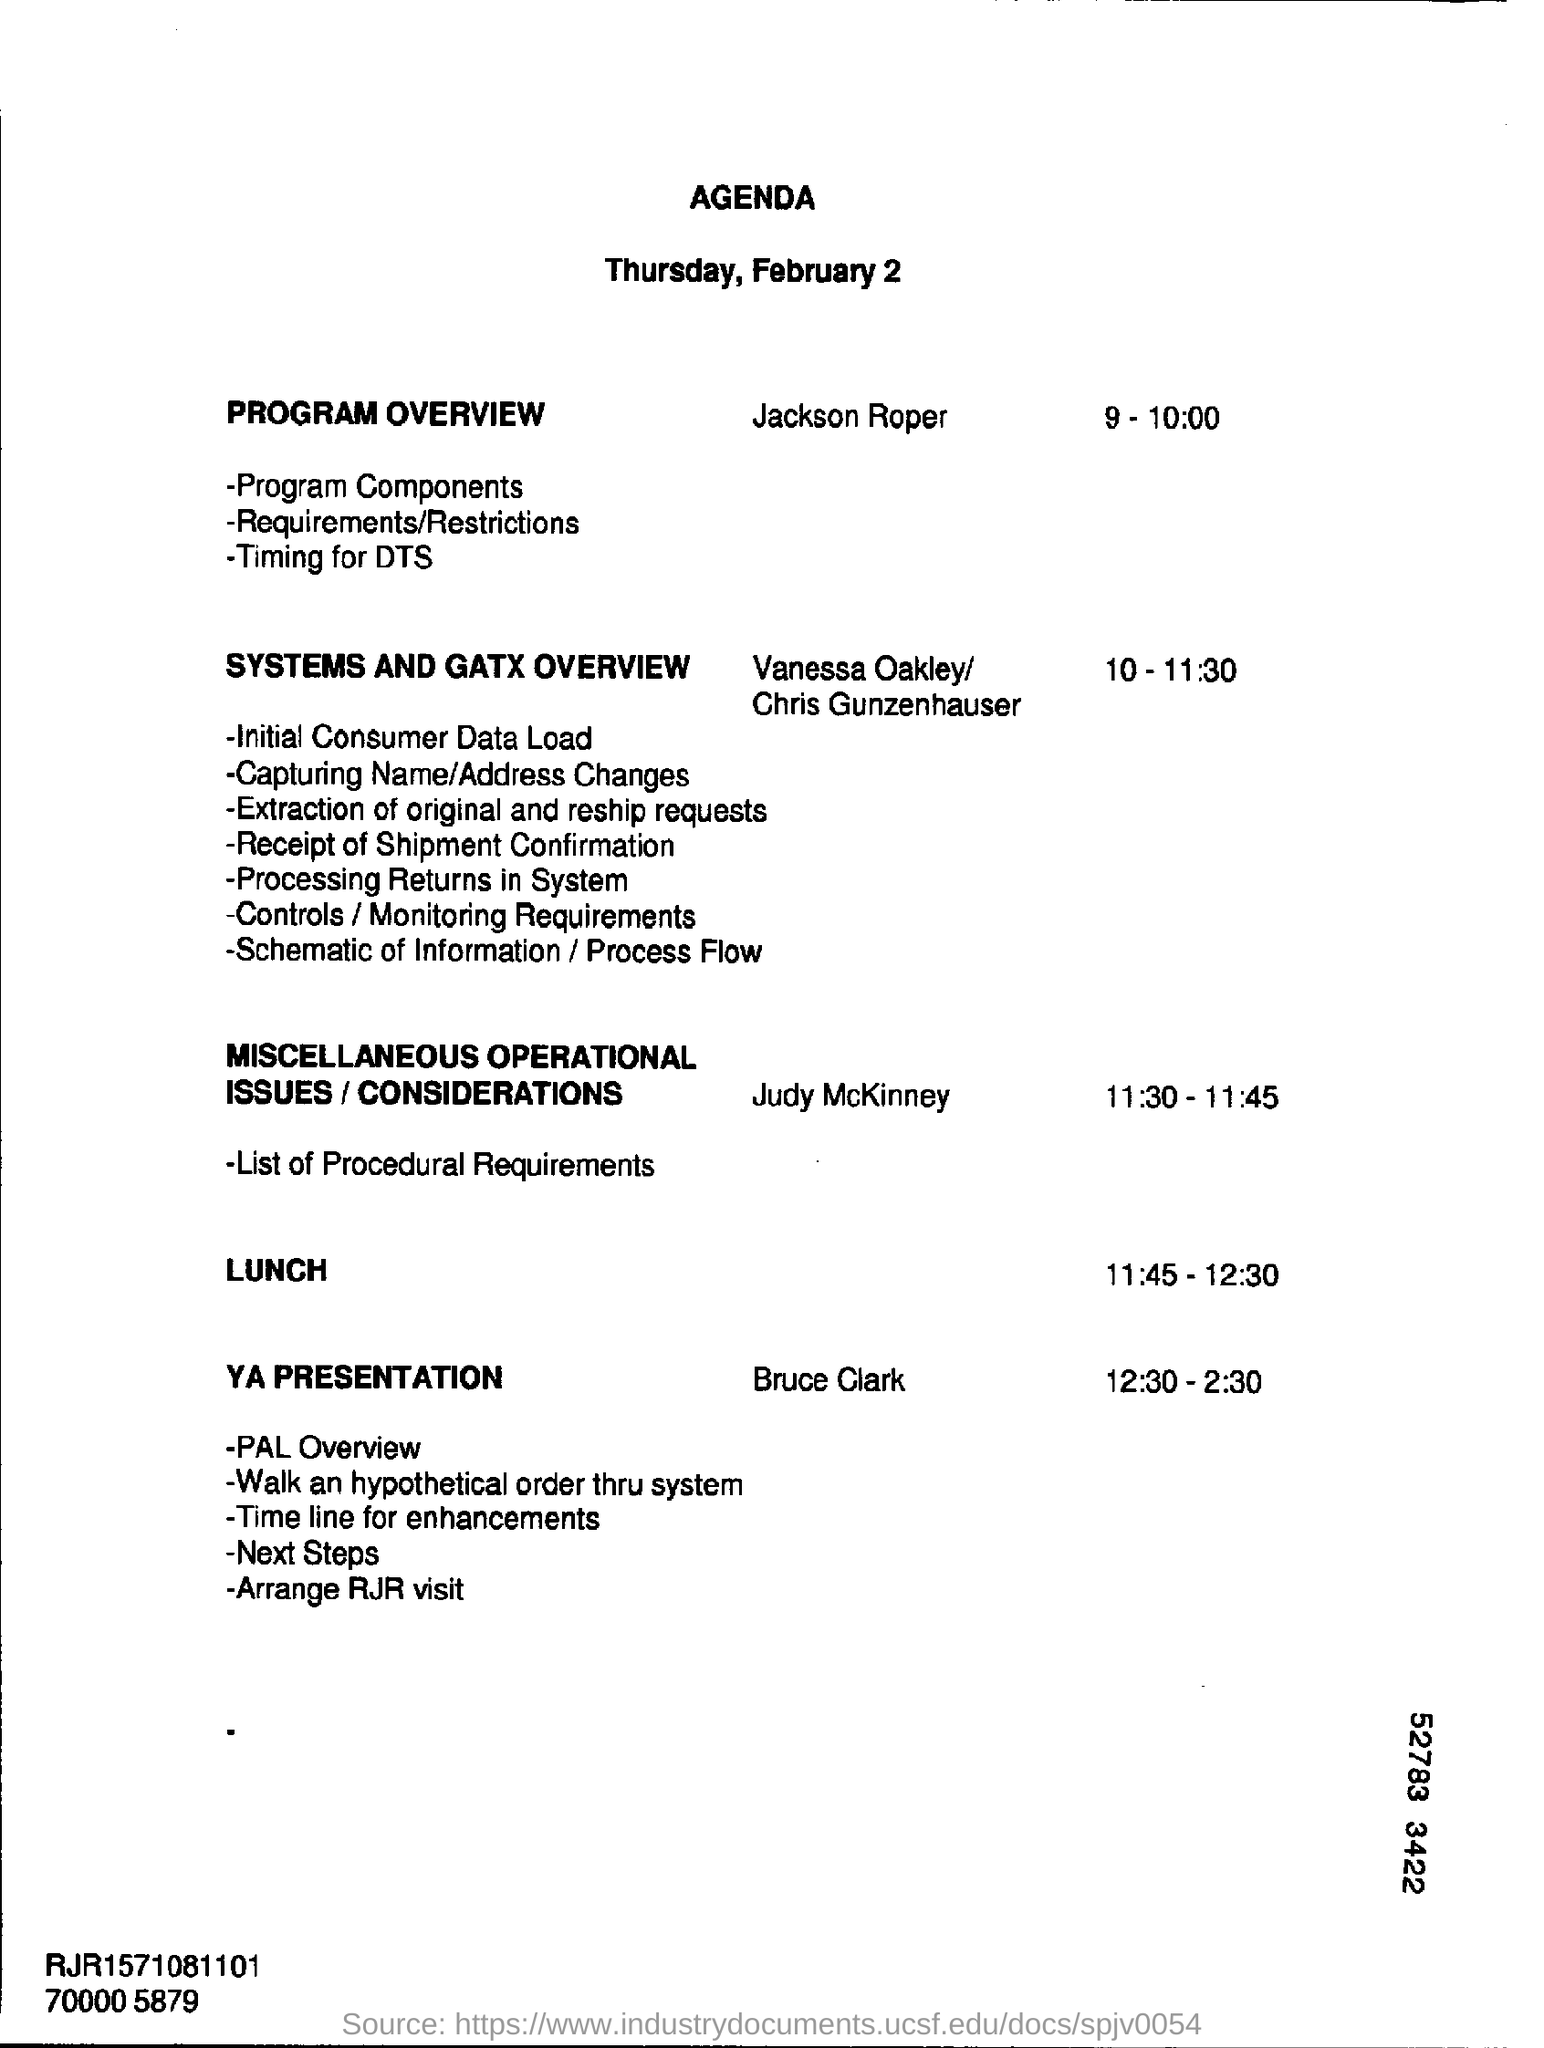What is time mentioned for "Time for miscellaneous operational issues?
Make the answer very short. 11.30-11.45. Who speaks or handle the session "YA Presentation"?
Offer a terse response. Bruce Clark. What is time mentioned for "YA Presentation"??
Offer a terse response. 12.30-2.30. Find out the title or head line of this page?
Offer a terse response. Agenda. Find out the day February 2 as mentioned ?
Your answer should be compact. Thursday. What the date mentioned in this page?
Give a very brief answer. February 2. What is the time mentioned for "Program Overview"?
Your answer should be very brief. 9 - 10:00. What is time mentioned for "Systems and gatx overview" ??
Your answer should be compact. 10 - 11:30. Who speaks about Program Overview?
Ensure brevity in your answer.  Jackson Roper. 